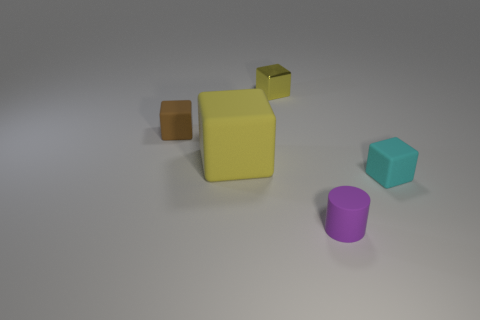Subtract all tiny cyan matte cubes. How many cubes are left? 3 Add 4 brown blocks. How many objects exist? 9 Subtract all brown blocks. How many blocks are left? 3 Subtract 2 cubes. How many cubes are left? 2 Subtract all cylinders. How many objects are left? 4 Subtract all green cubes. Subtract all green balls. How many cubes are left? 4 Subtract all gray balls. How many red cylinders are left? 0 Subtract all big purple matte cylinders. Subtract all small yellow things. How many objects are left? 4 Add 5 yellow metal things. How many yellow metal things are left? 6 Add 4 small cyan matte objects. How many small cyan matte objects exist? 5 